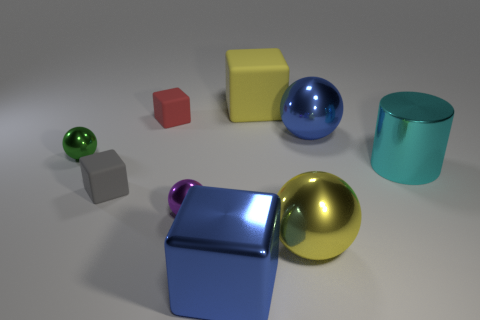What textures are present on the objects, and how does this affect the lighting? The objects in the image have varying textures; some are shiny and reflective like the large cube and spheres, while others, such as the small cube and cylinder, are more matte. The shiny surfaces create bright highlights and distinct reflections of the environment, whereas the matte textures scatter light more diffusely, providing a softer appearance. 